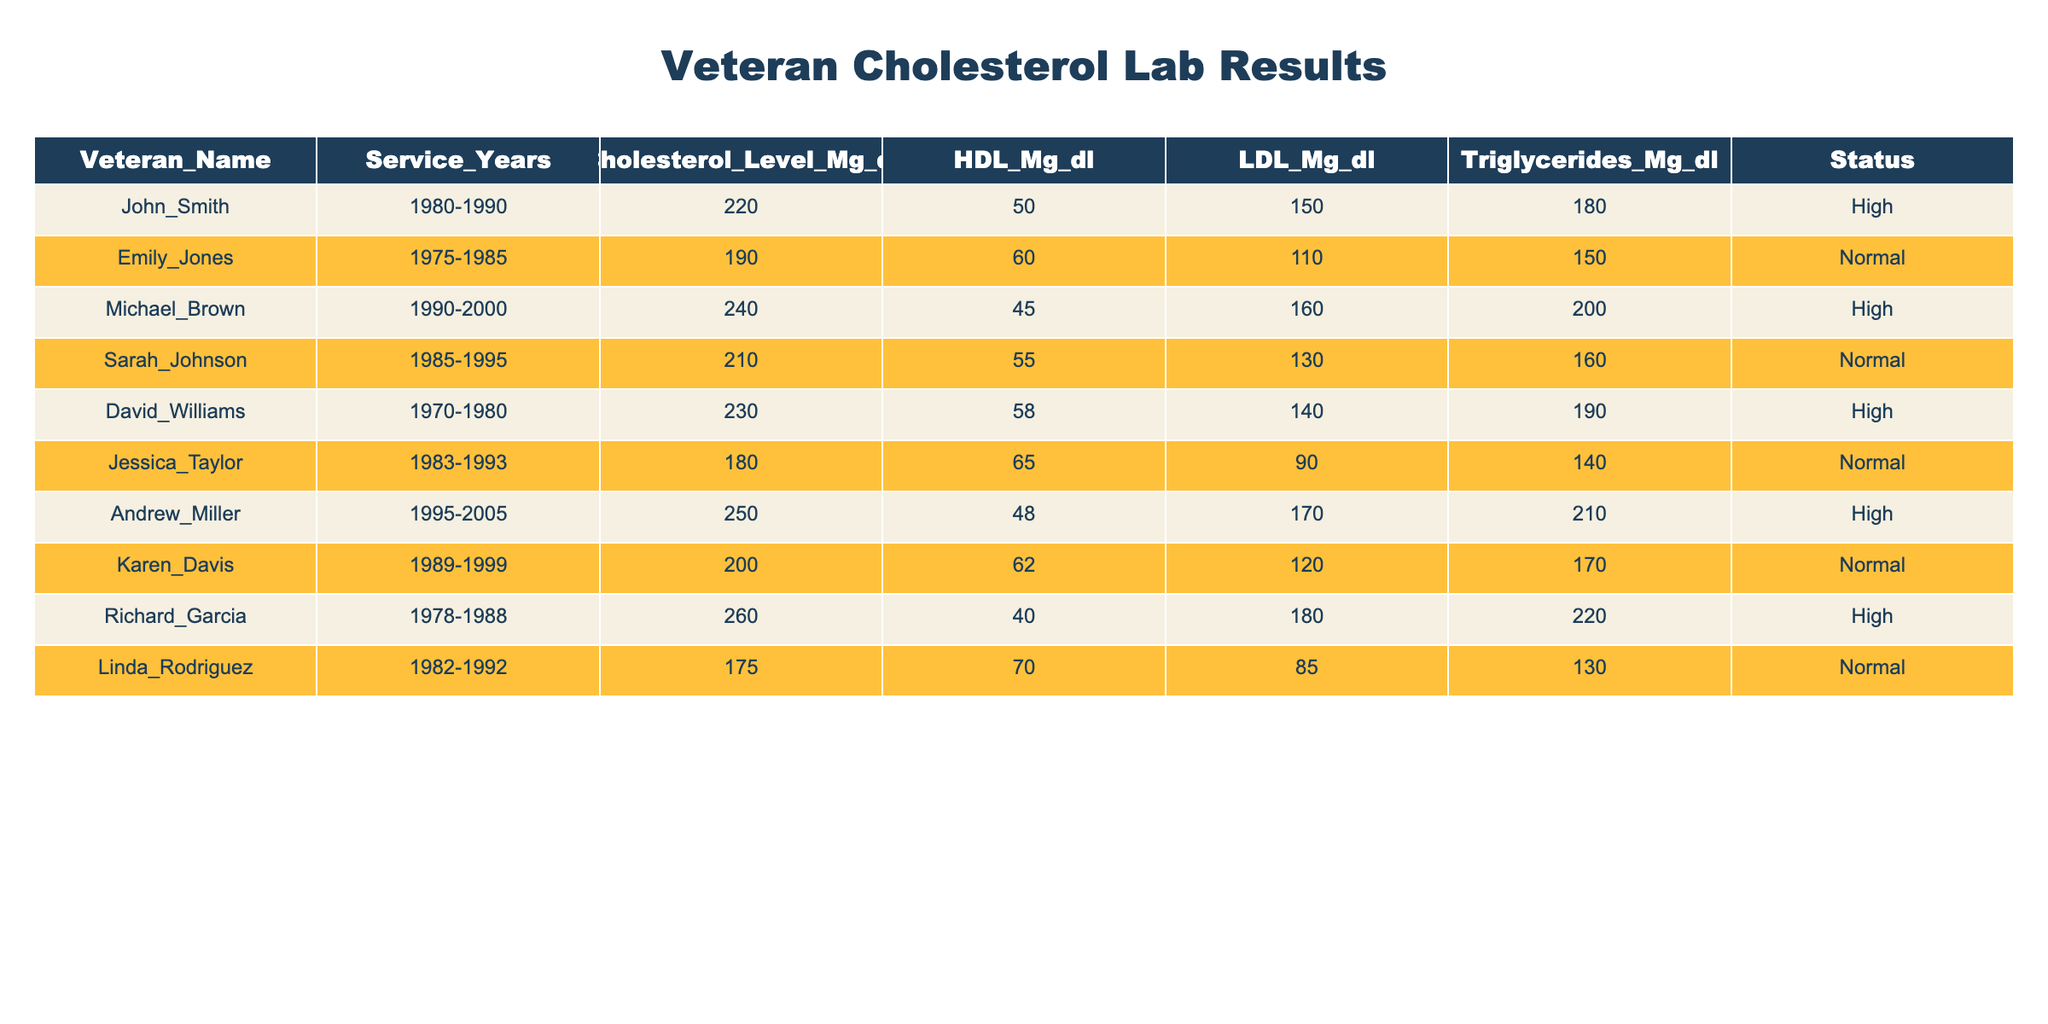What is the Cholesterol Level of Emily Jones? Looking at the table, find the row for Emily Jones and check the value under the Cholesterol Level column, which is 190 mg/dl.
Answer: 190 mg/dl How many veterans have Cholesterol Levels classified as High? Count the rows where the Status is marked as High. In the provided data, there are 5 veterans with High cholesterol levels.
Answer: 5 What is the average LDL level for veterans with a Normal status? Identify the LDL levels for veterans marked as Normal. Those are 110, 130, 120, and 85. The sum is 445, and there are 4 data points. Therefore, the average is 445 / 4 = 111.25.
Answer: 111.25 Did Richard Garcia's cholesterol level exceed 250 mg/dl? Check Richard Garcia's Cholesterol Level, which is listed as 260 mg/dl. Since 260 is greater than 250, the statement is true.
Answer: Yes Which veteran has the highest Triglycerides level and what is that level? Look at the Triglycerides column and find the maximum value. Andrew Miller has the highest Triglycerides level of 210 mg/dl.
Answer: Andrew Miller, 210 mg/dl What is the difference between the highest and lowest HDL levels among the veterans? The highest HDL level is 70 mg/dl (Linda Rodriguez) and the lowest is 40 mg/dl (Richard Garcia). The difference is 70 - 40 = 30 mg/dl.
Answer: 30 mg/dl How many veterans served from the 1980s and had Normal cholesterol levels? From the table, the veterans are Sarah Johnson, Jessica Taylor, and Karen Davis, who all served in the 1980s and have Normal status. That gives a total of 3 veterans.
Answer: 3 What are the Cholesterol Levels of veterans who served for more than 15 years? Filter the data for veterans who served more than 15 years. The levels are 220, 190, 240, 210, 230, 180, 250, 200, 260, and 175. The average can be calculated, but answering the question requests the cholesterol levels.
Answer: 220, 190, 240, 210, 230, 180, 250, 200, 260, 175 Is it true that all veterans have HDL levels above 40 mg/dl? Check the HDL levels listed for each veteran. Since the lowest HDL level is 40 mg/dl (Richard Garcia), it is true that none have levels below this.
Answer: Yes 